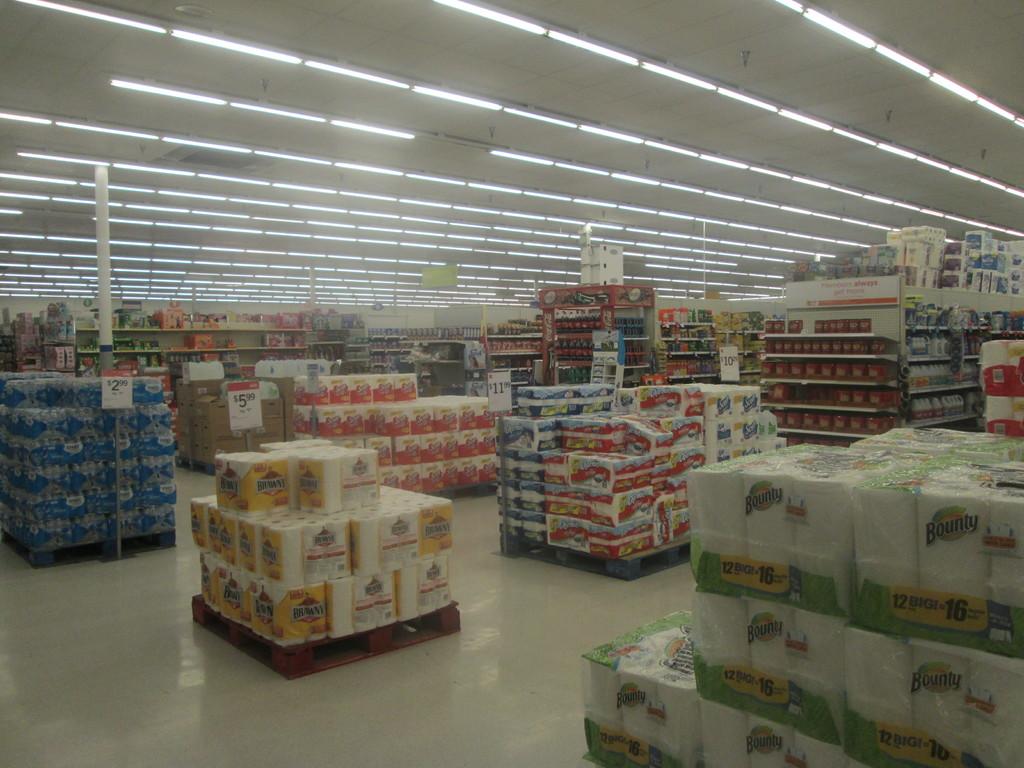How much are the paper towels selling for?
Provide a short and direct response. 5.99. How much is the bottle water selling for?
Ensure brevity in your answer.  2.99. 